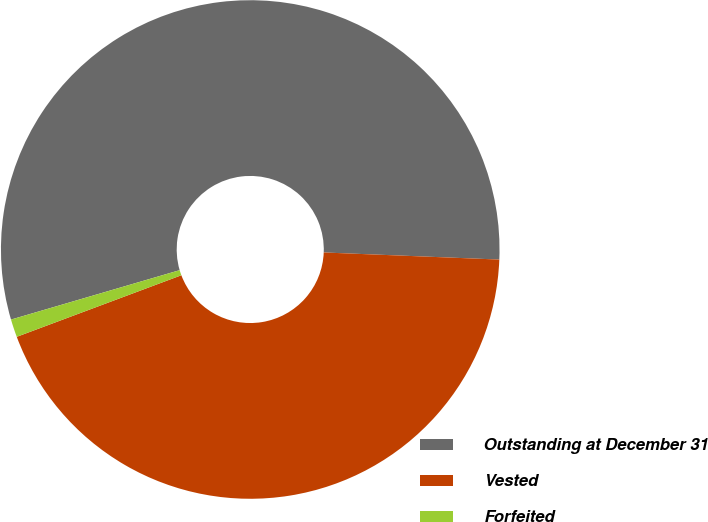Convert chart. <chart><loc_0><loc_0><loc_500><loc_500><pie_chart><fcel>Outstanding at December 31<fcel>Vested<fcel>Forfeited<nl><fcel>55.18%<fcel>43.66%<fcel>1.16%<nl></chart> 